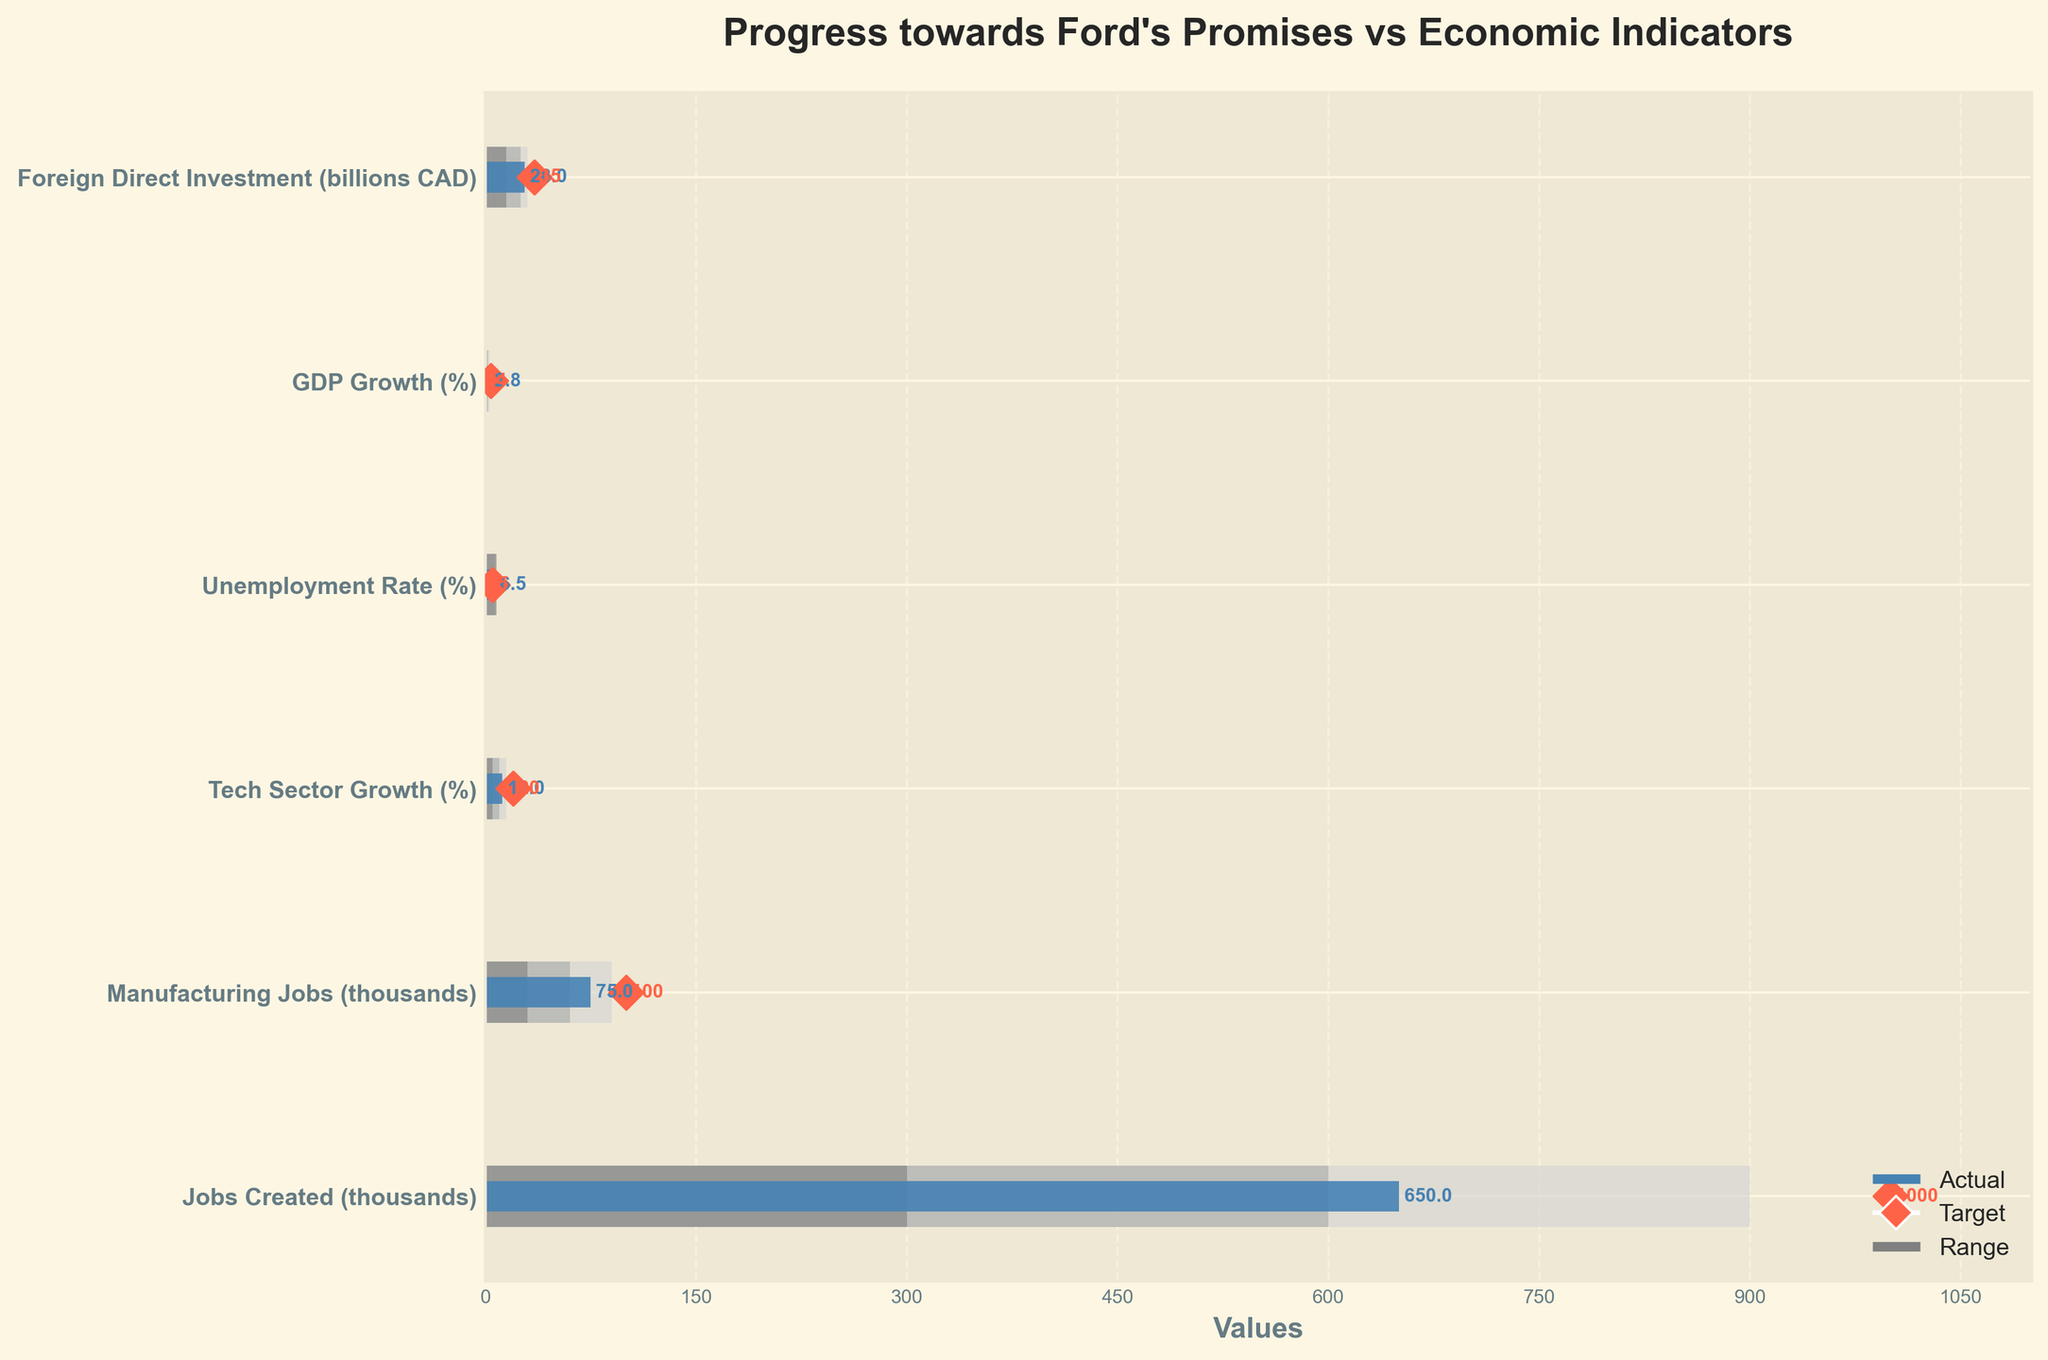What is the title of the bullet chart? The title of the chart is usually found at the top and it provides an overview of what the chart is about.
Answer: Progress towards Ford's Promises vs Economic Indicators What is the actual value of jobs created in thousands? Find the "Actual" value for "Jobs Created (thousands)" on the vertical bar to get the answer.
Answer: 650 What are the target values for all economic indicators? Look for the targets marked with diamonds and listed beside each indicator in the chart.
Answer: 1000 (Jobs Created), 100 (Manufacturing Jobs), 20% (Tech Sector Growth), 5% (Unemployment Rate), 4% (GDP Growth), 35 billion CAD (Foreign Direct Investment) Which economic indicator has exceeded its target range? Check each indicator to see if the actual value surpasses its target range (marked by the diamond symbol).
Answer: None How does the actual unemployment rate compare to the target? Look at the "Unemployment Rate (%)" data; compare the actual value (bar) to the target value (diamond).
Answer: The actual unemployment rate is higher than the target (6.5% vs 5%) Which economic indicator has the smallest difference between actual value and target? Calculate the absolute difference between actual and target for each indicator. Compare these differences to find the smallest one.
Answer: Tech Sector Growth (%), difference = 20% - 12% = 8% Which range does the actual value of manufacturing jobs fall into? Look at the bar for "Manufacturing Jobs (thousands)" and see where it falls in the ranges of #D3D3D3, #A9A9A9, and #808080.
Answer: Middle range (30 to 60) What is the sum of all the actual values for the economic indicators? Add all the actual values together: 650 + 75 + 12 + 6.5 + 2.8 + 28.
Answer: 774.3 How many indicators achieved at least the first range (Range1)? Count the number of bars that reach or exceed the first range (indicated by the length of the first shaded area).
Answer: 5 indicators 